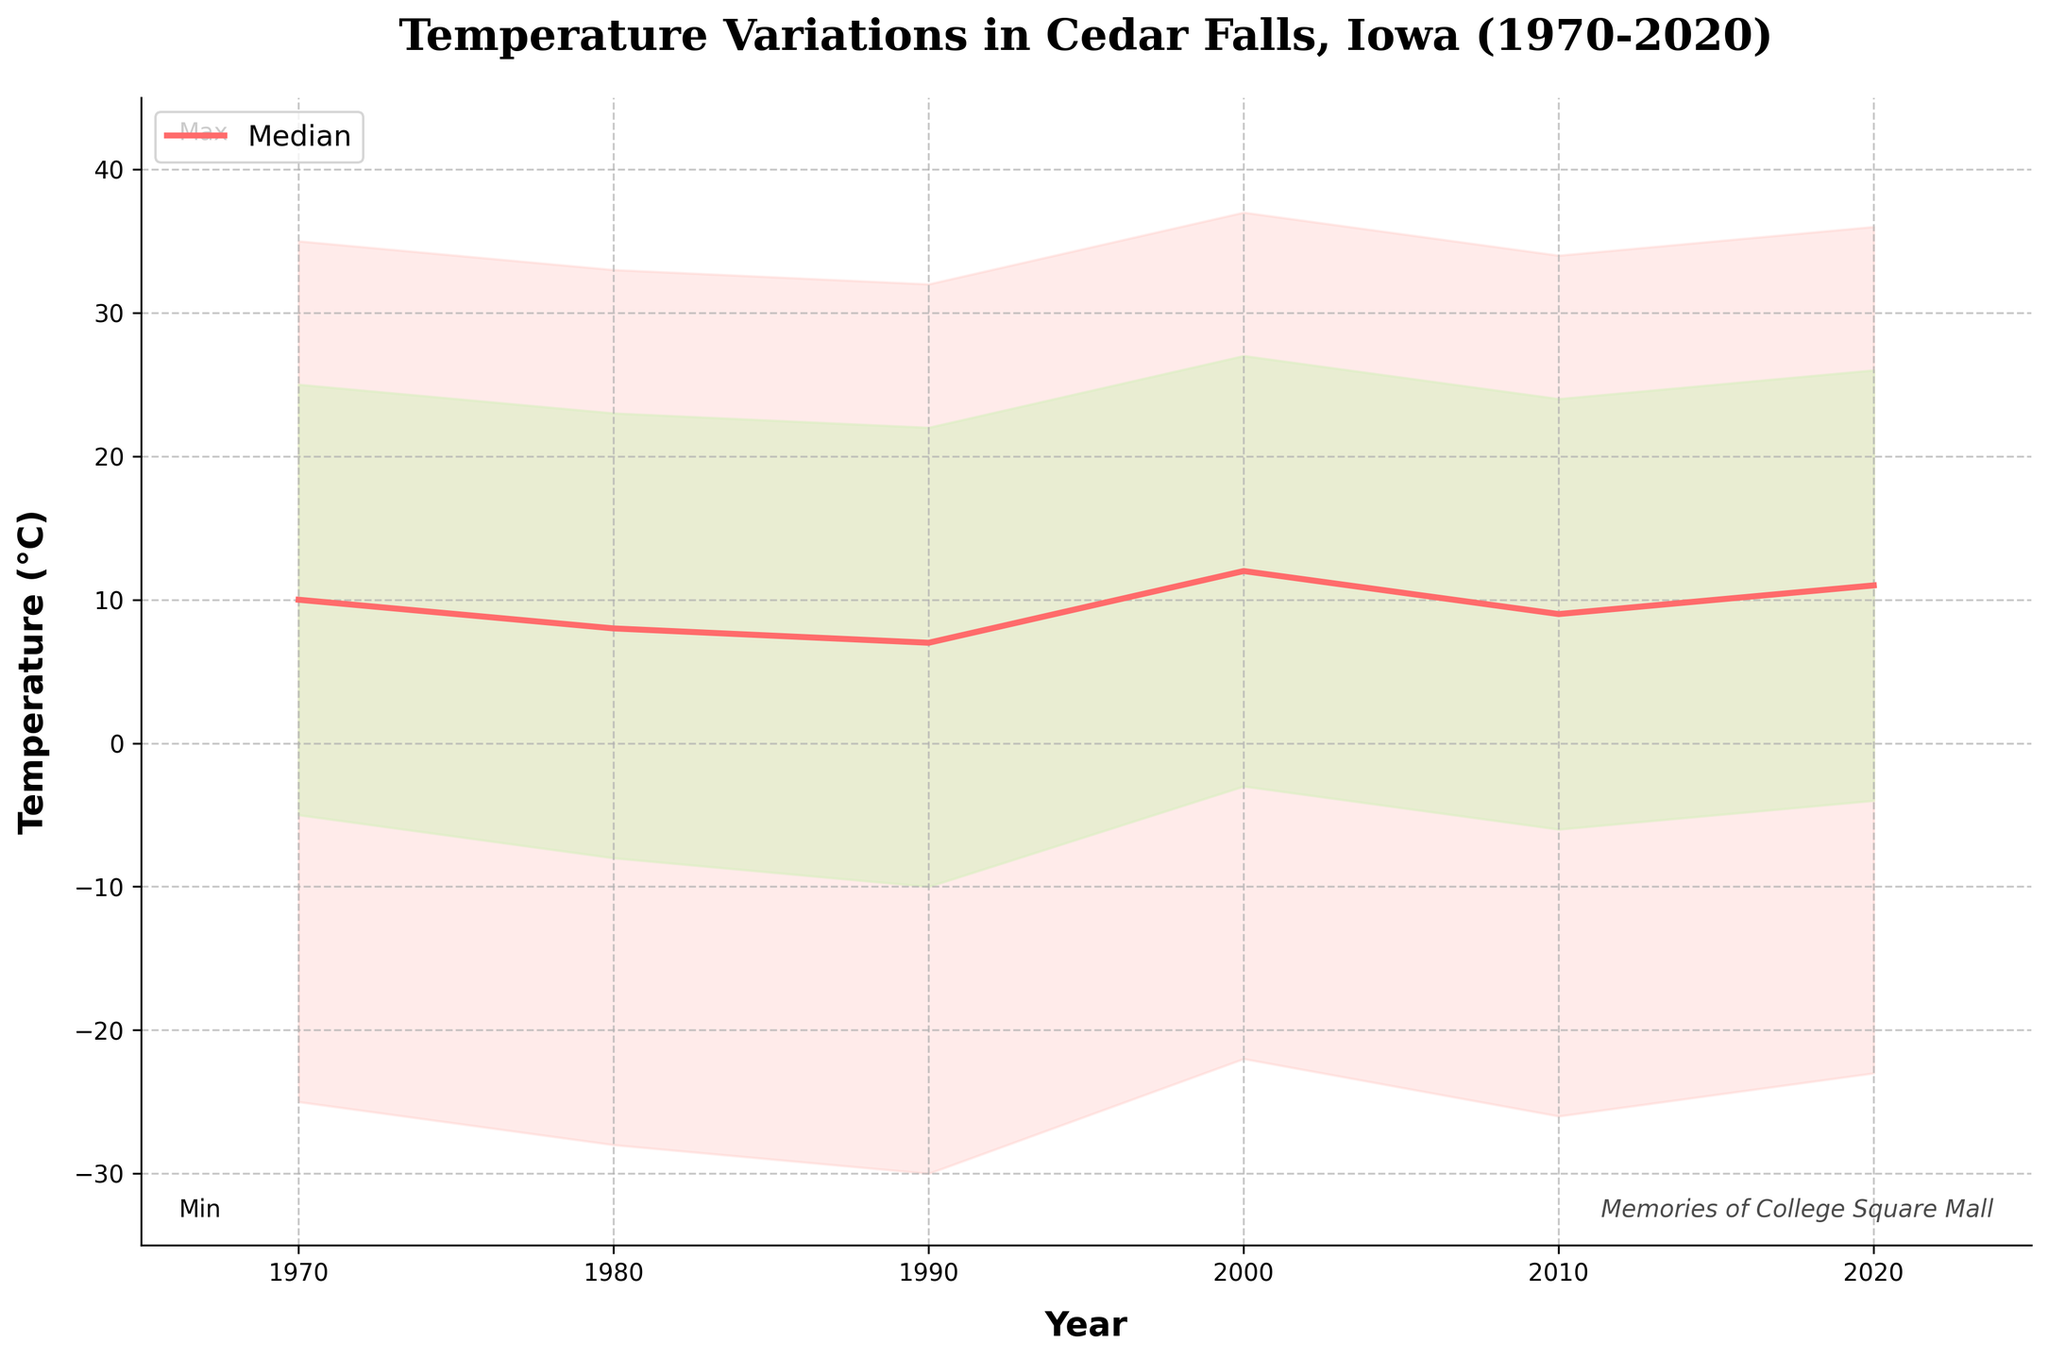what is the temperature range in Cedar Falls, Iowa in 1970? The temperature range can be calculated by subtracting the minimum temperature from the maximum temperature in 1970. This gives us 35 - (-25) = 60 degrees.
Answer: 60 degrees what is the general trend in the median temperature from 1970 to 2020? Observing the median temperature values plotted on the chart from 1970 to 2020, it is evident that the median temperature has a slightly increasing trend, rising from 10 degrees in 1970 to 11 degrees in 2020.
Answer: Slightly increasing How do the lower quartile temperatures compare between 1980 and 2000? The lower quartile temperature in 1980 is -8 degrees, while in 2000 it is -3 degrees. Comparing the two temperatures, -3 degrees in 2000 is higher.
Answer: Higher in 2000 By how much did the minimum temperature drop from 1970 to 1990? The minimum temperature in 1970 is -25 degrees, and in 1990 it is -30 degrees. The drop is calculated as -25 - (-30) = 5 degrees.
Answer: 5 degrees Comparing the maximum temperatures, which year had a higher maximum temperature: 2000 or 2010? In 2000, the maximum temperature was 37 degrees, and in 2010, it was 34 degrees. Therefore, 2000 had the higher maximum temperature.
Answer: 2000 How much did the median temperature change from 1970 to 2020? The median temperature in 1970 was 10 degrees, and in 2020, it was 11 degrees. The change is calculated as 11 - 10 = 1 degree.
Answer: 1 degree How does the 1990 temperature range compare to that of 2020? In 1990, the temperature range (Max-Min) was 32 - (-30) = 62 degrees. In 2020, it was 36 - (-23) = 59 degrees. Therefore, the range in 1990 was slightly larger.
Answer: Slightly larger in 1990 In which year did the upper quartile temperature reach its highest value, and what was it? By inspecting the fan chart, the highest upper quartile temperature occurred in the year 2000, with a value of 27 degrees.
Answer: 2000, 27 degrees Analyzing the chart, can you identify any specific outlier years where the maximum or minimum temperatures deviate significantly from other years? Both the minimum and maximum temperatures in 1990 appear to be outliers as the minimum reaches -30 degrees and the maximum is relatively low compared to other years.
Answer: 1990 